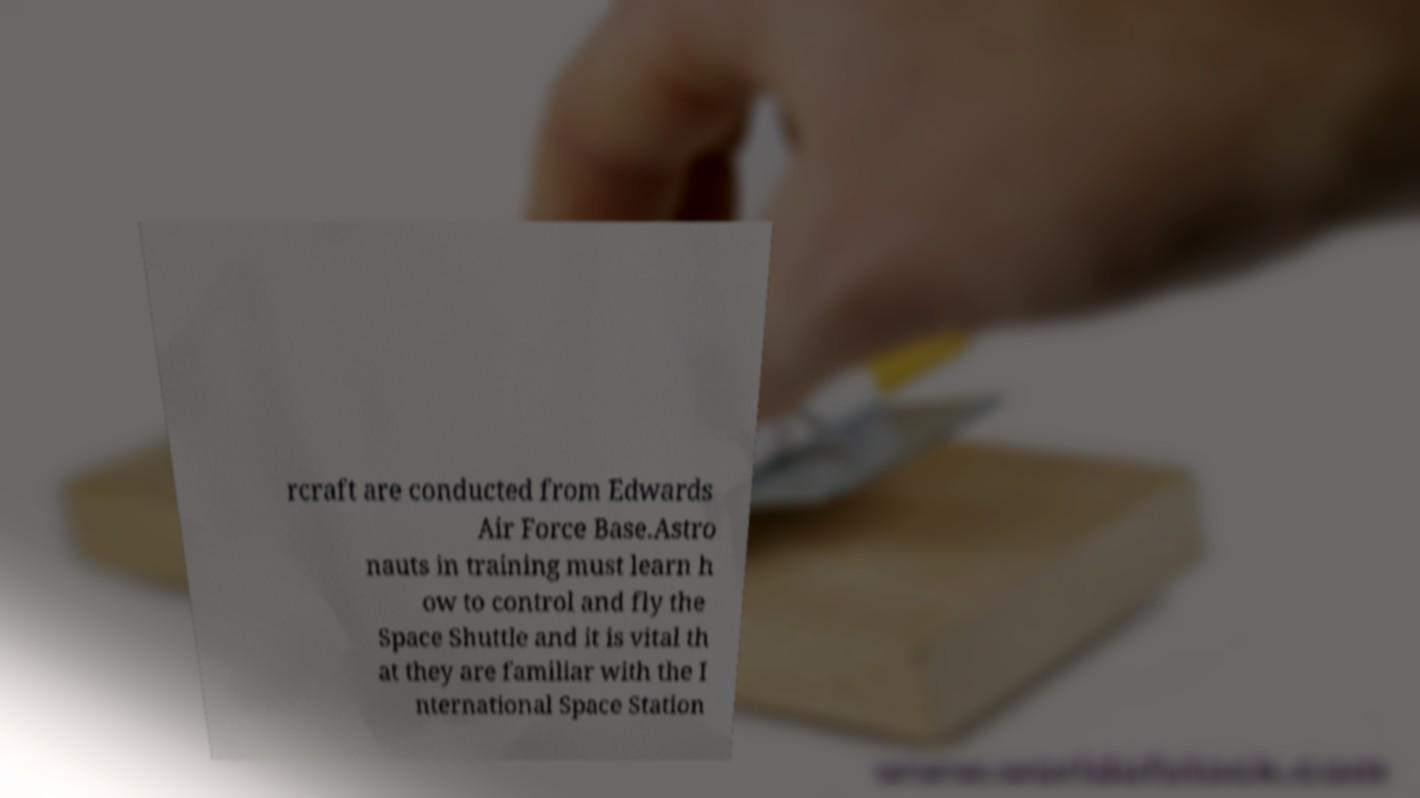There's text embedded in this image that I need extracted. Can you transcribe it verbatim? rcraft are conducted from Edwards Air Force Base.Astro nauts in training must learn h ow to control and fly the Space Shuttle and it is vital th at they are familiar with the I nternational Space Station 